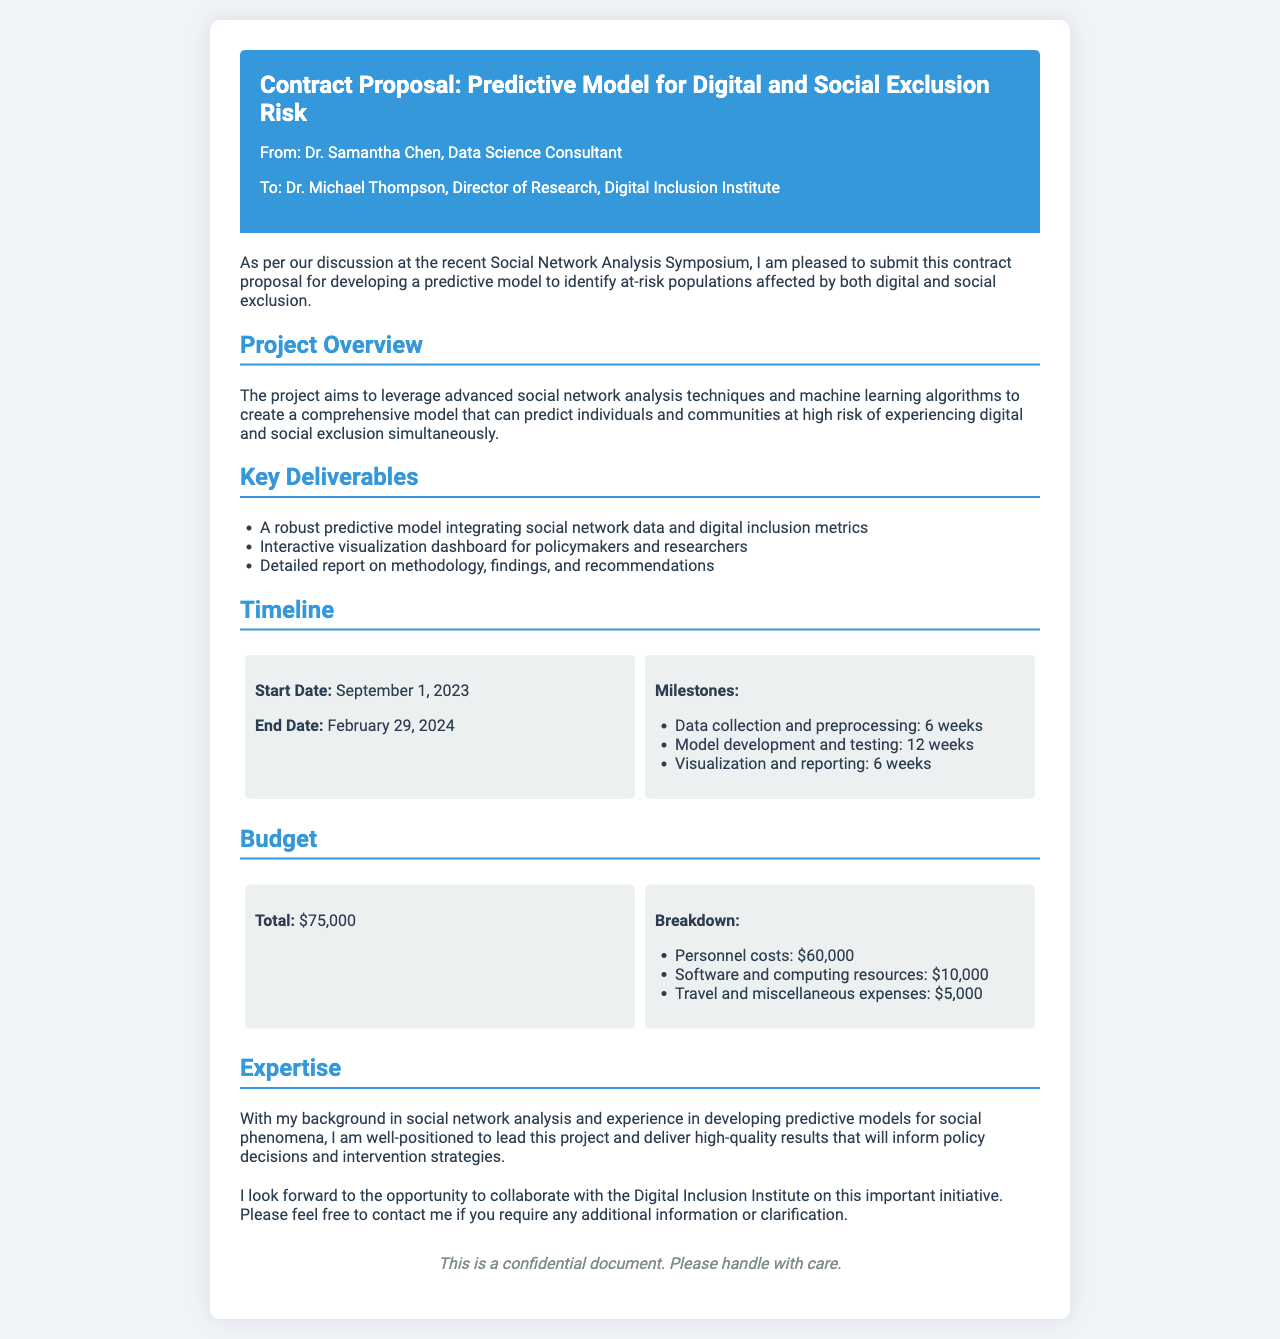What is the total budget for the project? The total budget is clearly stated in the document under the Budget section, which totals $75,000.
Answer: $75,000 Who is the recipient of the contract proposal? The recipient is mentioned at the beginning of the document as Dr. Michael Thompson, Director of Research, Digital Inclusion Institute.
Answer: Dr. Michael Thompson What is the start date of the project? The start date is specified in the Timeline section as September 1, 2023.
Answer: September 1, 2023 What is one of the key deliverables mentioned? One of the key deliverables is listed under the Key Deliverables section as an interactive visualization dashboard for policymakers and researchers.
Answer: Interactive visualization dashboard How long is the model development and testing phase? The duration for model development and testing is indicated in the Timeline section as 12 weeks.
Answer: 12 weeks What is Dr. Samantha Chen's expertise? Dr. Samantha Chen's expertise is detailed in the Expertise section, mentioning her background in social network analysis and predictive models for social phenomena.
Answer: Social network analysis What is the end date of the project? The end date is provided in the Timeline section as February 29, 2024.
Answer: February 29, 2024 What is included in the personnel costs? The personnel costs section lists the total amount allocated for personnel as $60,000.
Answer: $60,000 What is the primary aim of the project? The primary aim is stated in the Project Overview section to develop a predictive model to identify at-risk populations affected by both digital and social exclusion.
Answer: Identify at-risk populations 